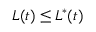<formula> <loc_0><loc_0><loc_500><loc_500>L ( t ) \leq L ^ { * } ( t )</formula> 